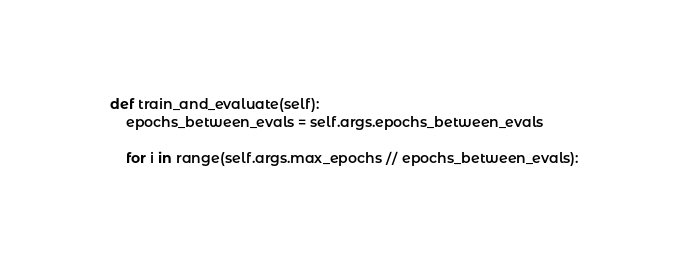Convert code to text. <code><loc_0><loc_0><loc_500><loc_500><_Python_>    def train_and_evaluate(self):
        epochs_between_evals = self.args.epochs_between_evals

        for i in range(self.args.max_epochs // epochs_between_evals):
</code> 